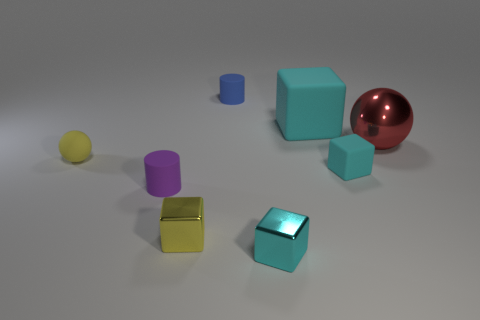What colors are present in the image, and what do they convey? The image contains a palette of colors including yellow, purple, teal, red, and a pale shade of yellow. Each color adds to the image's visual interest, with the bright red sphere drawing attention as a focal point and the diverse colors of the other objects providing contrast and variety. 